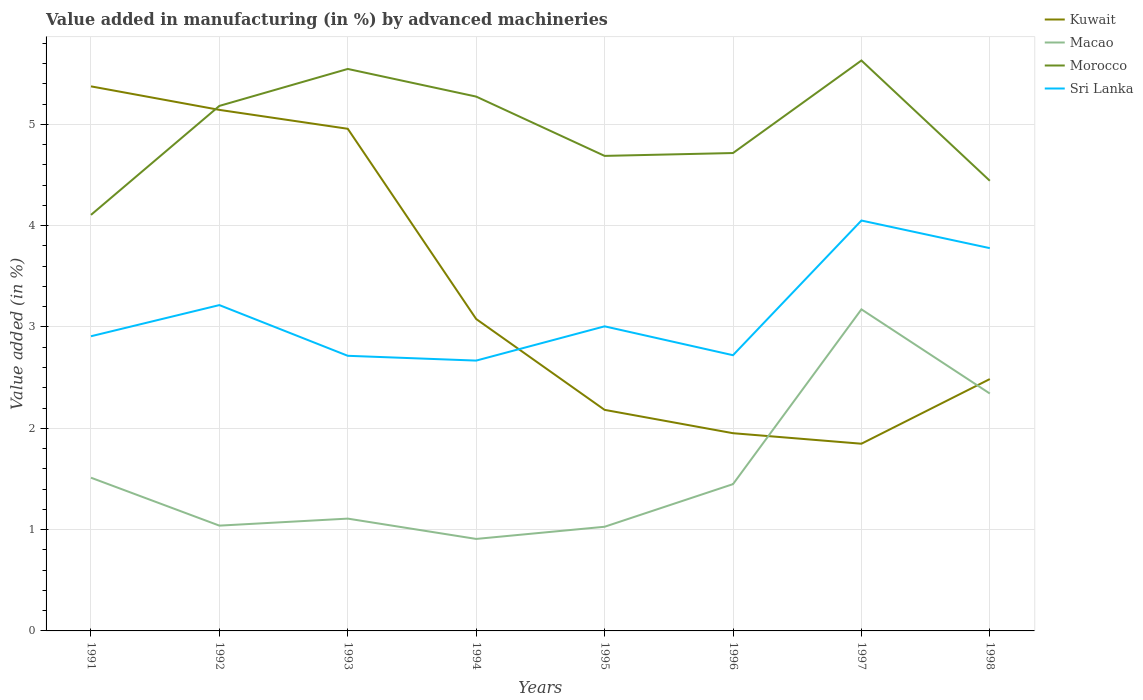Across all years, what is the maximum percentage of value added in manufacturing by advanced machineries in Kuwait?
Make the answer very short. 1.85. What is the total percentage of value added in manufacturing by advanced machineries in Sri Lanka in the graph?
Provide a short and direct response. -1.38. What is the difference between the highest and the second highest percentage of value added in manufacturing by advanced machineries in Macao?
Offer a terse response. 2.27. Is the percentage of value added in manufacturing by advanced machineries in Morocco strictly greater than the percentage of value added in manufacturing by advanced machineries in Sri Lanka over the years?
Your answer should be compact. No. How many lines are there?
Provide a succinct answer. 4. Are the values on the major ticks of Y-axis written in scientific E-notation?
Offer a terse response. No. Does the graph contain grids?
Your answer should be very brief. Yes. How are the legend labels stacked?
Ensure brevity in your answer.  Vertical. What is the title of the graph?
Provide a short and direct response. Value added in manufacturing (in %) by advanced machineries. Does "Liberia" appear as one of the legend labels in the graph?
Ensure brevity in your answer.  No. What is the label or title of the X-axis?
Give a very brief answer. Years. What is the label or title of the Y-axis?
Ensure brevity in your answer.  Value added (in %). What is the Value added (in %) in Kuwait in 1991?
Make the answer very short. 5.38. What is the Value added (in %) in Macao in 1991?
Your response must be concise. 1.51. What is the Value added (in %) of Morocco in 1991?
Your response must be concise. 4.11. What is the Value added (in %) in Sri Lanka in 1991?
Ensure brevity in your answer.  2.91. What is the Value added (in %) of Kuwait in 1992?
Provide a short and direct response. 5.14. What is the Value added (in %) of Macao in 1992?
Keep it short and to the point. 1.04. What is the Value added (in %) in Morocco in 1992?
Give a very brief answer. 5.18. What is the Value added (in %) in Sri Lanka in 1992?
Your answer should be very brief. 3.22. What is the Value added (in %) in Kuwait in 1993?
Your response must be concise. 4.96. What is the Value added (in %) of Macao in 1993?
Give a very brief answer. 1.11. What is the Value added (in %) of Morocco in 1993?
Make the answer very short. 5.55. What is the Value added (in %) of Sri Lanka in 1993?
Provide a short and direct response. 2.72. What is the Value added (in %) in Kuwait in 1994?
Provide a succinct answer. 3.08. What is the Value added (in %) of Macao in 1994?
Your response must be concise. 0.91. What is the Value added (in %) in Morocco in 1994?
Offer a very short reply. 5.27. What is the Value added (in %) of Sri Lanka in 1994?
Your answer should be compact. 2.67. What is the Value added (in %) of Kuwait in 1995?
Ensure brevity in your answer.  2.18. What is the Value added (in %) in Macao in 1995?
Your answer should be very brief. 1.03. What is the Value added (in %) in Morocco in 1995?
Offer a terse response. 4.69. What is the Value added (in %) in Sri Lanka in 1995?
Your answer should be very brief. 3.01. What is the Value added (in %) in Kuwait in 1996?
Your response must be concise. 1.95. What is the Value added (in %) in Macao in 1996?
Your answer should be compact. 1.45. What is the Value added (in %) of Morocco in 1996?
Keep it short and to the point. 4.72. What is the Value added (in %) in Sri Lanka in 1996?
Provide a succinct answer. 2.72. What is the Value added (in %) in Kuwait in 1997?
Offer a very short reply. 1.85. What is the Value added (in %) in Macao in 1997?
Your response must be concise. 3.17. What is the Value added (in %) of Morocco in 1997?
Offer a terse response. 5.63. What is the Value added (in %) in Sri Lanka in 1997?
Keep it short and to the point. 4.05. What is the Value added (in %) in Kuwait in 1998?
Give a very brief answer. 2.49. What is the Value added (in %) of Macao in 1998?
Keep it short and to the point. 2.34. What is the Value added (in %) in Morocco in 1998?
Keep it short and to the point. 4.44. What is the Value added (in %) of Sri Lanka in 1998?
Ensure brevity in your answer.  3.78. Across all years, what is the maximum Value added (in %) in Kuwait?
Make the answer very short. 5.38. Across all years, what is the maximum Value added (in %) in Macao?
Offer a very short reply. 3.17. Across all years, what is the maximum Value added (in %) of Morocco?
Provide a short and direct response. 5.63. Across all years, what is the maximum Value added (in %) of Sri Lanka?
Make the answer very short. 4.05. Across all years, what is the minimum Value added (in %) of Kuwait?
Offer a very short reply. 1.85. Across all years, what is the minimum Value added (in %) in Macao?
Provide a short and direct response. 0.91. Across all years, what is the minimum Value added (in %) of Morocco?
Ensure brevity in your answer.  4.11. Across all years, what is the minimum Value added (in %) in Sri Lanka?
Your answer should be very brief. 2.67. What is the total Value added (in %) of Kuwait in the graph?
Offer a very short reply. 27.02. What is the total Value added (in %) in Macao in the graph?
Your answer should be very brief. 12.56. What is the total Value added (in %) in Morocco in the graph?
Offer a very short reply. 39.59. What is the total Value added (in %) in Sri Lanka in the graph?
Your answer should be compact. 25.07. What is the difference between the Value added (in %) of Kuwait in 1991 and that in 1992?
Offer a very short reply. 0.23. What is the difference between the Value added (in %) of Macao in 1991 and that in 1992?
Offer a very short reply. 0.47. What is the difference between the Value added (in %) of Morocco in 1991 and that in 1992?
Provide a short and direct response. -1.08. What is the difference between the Value added (in %) of Sri Lanka in 1991 and that in 1992?
Keep it short and to the point. -0.31. What is the difference between the Value added (in %) in Kuwait in 1991 and that in 1993?
Provide a succinct answer. 0.42. What is the difference between the Value added (in %) of Macao in 1991 and that in 1993?
Provide a short and direct response. 0.4. What is the difference between the Value added (in %) of Morocco in 1991 and that in 1993?
Offer a terse response. -1.44. What is the difference between the Value added (in %) in Sri Lanka in 1991 and that in 1993?
Provide a succinct answer. 0.19. What is the difference between the Value added (in %) of Kuwait in 1991 and that in 1994?
Give a very brief answer. 2.3. What is the difference between the Value added (in %) in Macao in 1991 and that in 1994?
Offer a very short reply. 0.6. What is the difference between the Value added (in %) in Morocco in 1991 and that in 1994?
Provide a succinct answer. -1.17. What is the difference between the Value added (in %) in Sri Lanka in 1991 and that in 1994?
Make the answer very short. 0.24. What is the difference between the Value added (in %) of Kuwait in 1991 and that in 1995?
Give a very brief answer. 3.19. What is the difference between the Value added (in %) of Macao in 1991 and that in 1995?
Provide a succinct answer. 0.48. What is the difference between the Value added (in %) of Morocco in 1991 and that in 1995?
Make the answer very short. -0.58. What is the difference between the Value added (in %) in Sri Lanka in 1991 and that in 1995?
Your answer should be very brief. -0.1. What is the difference between the Value added (in %) in Kuwait in 1991 and that in 1996?
Make the answer very short. 3.42. What is the difference between the Value added (in %) in Macao in 1991 and that in 1996?
Provide a short and direct response. 0.06. What is the difference between the Value added (in %) in Morocco in 1991 and that in 1996?
Offer a terse response. -0.61. What is the difference between the Value added (in %) in Sri Lanka in 1991 and that in 1996?
Give a very brief answer. 0.19. What is the difference between the Value added (in %) of Kuwait in 1991 and that in 1997?
Your answer should be compact. 3.53. What is the difference between the Value added (in %) of Macao in 1991 and that in 1997?
Your answer should be compact. -1.66. What is the difference between the Value added (in %) of Morocco in 1991 and that in 1997?
Your response must be concise. -1.52. What is the difference between the Value added (in %) in Sri Lanka in 1991 and that in 1997?
Offer a terse response. -1.14. What is the difference between the Value added (in %) in Kuwait in 1991 and that in 1998?
Provide a short and direct response. 2.89. What is the difference between the Value added (in %) of Macao in 1991 and that in 1998?
Make the answer very short. -0.83. What is the difference between the Value added (in %) of Morocco in 1991 and that in 1998?
Give a very brief answer. -0.34. What is the difference between the Value added (in %) of Sri Lanka in 1991 and that in 1998?
Your answer should be compact. -0.87. What is the difference between the Value added (in %) in Kuwait in 1992 and that in 1993?
Offer a terse response. 0.19. What is the difference between the Value added (in %) of Macao in 1992 and that in 1993?
Your answer should be compact. -0.07. What is the difference between the Value added (in %) of Morocco in 1992 and that in 1993?
Keep it short and to the point. -0.36. What is the difference between the Value added (in %) in Sri Lanka in 1992 and that in 1993?
Give a very brief answer. 0.5. What is the difference between the Value added (in %) in Kuwait in 1992 and that in 1994?
Keep it short and to the point. 2.06. What is the difference between the Value added (in %) in Macao in 1992 and that in 1994?
Your answer should be compact. 0.13. What is the difference between the Value added (in %) in Morocco in 1992 and that in 1994?
Offer a very short reply. -0.09. What is the difference between the Value added (in %) of Sri Lanka in 1992 and that in 1994?
Your answer should be compact. 0.55. What is the difference between the Value added (in %) in Kuwait in 1992 and that in 1995?
Provide a succinct answer. 2.96. What is the difference between the Value added (in %) of Macao in 1992 and that in 1995?
Your answer should be compact. 0.01. What is the difference between the Value added (in %) of Morocco in 1992 and that in 1995?
Your answer should be compact. 0.49. What is the difference between the Value added (in %) of Sri Lanka in 1992 and that in 1995?
Offer a terse response. 0.21. What is the difference between the Value added (in %) of Kuwait in 1992 and that in 1996?
Make the answer very short. 3.19. What is the difference between the Value added (in %) of Macao in 1992 and that in 1996?
Your answer should be very brief. -0.41. What is the difference between the Value added (in %) of Morocco in 1992 and that in 1996?
Offer a terse response. 0.47. What is the difference between the Value added (in %) of Sri Lanka in 1992 and that in 1996?
Your response must be concise. 0.49. What is the difference between the Value added (in %) of Kuwait in 1992 and that in 1997?
Provide a short and direct response. 3.3. What is the difference between the Value added (in %) of Macao in 1992 and that in 1997?
Keep it short and to the point. -2.13. What is the difference between the Value added (in %) of Morocco in 1992 and that in 1997?
Offer a very short reply. -0.45. What is the difference between the Value added (in %) of Sri Lanka in 1992 and that in 1997?
Your response must be concise. -0.83. What is the difference between the Value added (in %) in Kuwait in 1992 and that in 1998?
Your response must be concise. 2.66. What is the difference between the Value added (in %) of Macao in 1992 and that in 1998?
Keep it short and to the point. -1.3. What is the difference between the Value added (in %) of Morocco in 1992 and that in 1998?
Give a very brief answer. 0.74. What is the difference between the Value added (in %) in Sri Lanka in 1992 and that in 1998?
Offer a terse response. -0.56. What is the difference between the Value added (in %) in Kuwait in 1993 and that in 1994?
Keep it short and to the point. 1.88. What is the difference between the Value added (in %) of Macao in 1993 and that in 1994?
Provide a succinct answer. 0.2. What is the difference between the Value added (in %) in Morocco in 1993 and that in 1994?
Your response must be concise. 0.27. What is the difference between the Value added (in %) in Sri Lanka in 1993 and that in 1994?
Offer a very short reply. 0.05. What is the difference between the Value added (in %) of Kuwait in 1993 and that in 1995?
Your response must be concise. 2.77. What is the difference between the Value added (in %) in Macao in 1993 and that in 1995?
Your response must be concise. 0.08. What is the difference between the Value added (in %) of Morocco in 1993 and that in 1995?
Ensure brevity in your answer.  0.86. What is the difference between the Value added (in %) in Sri Lanka in 1993 and that in 1995?
Provide a short and direct response. -0.29. What is the difference between the Value added (in %) of Kuwait in 1993 and that in 1996?
Offer a terse response. 3. What is the difference between the Value added (in %) in Macao in 1993 and that in 1996?
Keep it short and to the point. -0.34. What is the difference between the Value added (in %) of Morocco in 1993 and that in 1996?
Your answer should be very brief. 0.83. What is the difference between the Value added (in %) in Sri Lanka in 1993 and that in 1996?
Make the answer very short. -0.01. What is the difference between the Value added (in %) in Kuwait in 1993 and that in 1997?
Offer a very short reply. 3.11. What is the difference between the Value added (in %) in Macao in 1993 and that in 1997?
Provide a short and direct response. -2.07. What is the difference between the Value added (in %) in Morocco in 1993 and that in 1997?
Provide a short and direct response. -0.08. What is the difference between the Value added (in %) of Sri Lanka in 1993 and that in 1997?
Make the answer very short. -1.34. What is the difference between the Value added (in %) of Kuwait in 1993 and that in 1998?
Your answer should be very brief. 2.47. What is the difference between the Value added (in %) of Macao in 1993 and that in 1998?
Your response must be concise. -1.23. What is the difference between the Value added (in %) in Morocco in 1993 and that in 1998?
Ensure brevity in your answer.  1.1. What is the difference between the Value added (in %) of Sri Lanka in 1993 and that in 1998?
Offer a terse response. -1.06. What is the difference between the Value added (in %) of Kuwait in 1994 and that in 1995?
Offer a very short reply. 0.9. What is the difference between the Value added (in %) of Macao in 1994 and that in 1995?
Give a very brief answer. -0.12. What is the difference between the Value added (in %) of Morocco in 1994 and that in 1995?
Provide a succinct answer. 0.59. What is the difference between the Value added (in %) of Sri Lanka in 1994 and that in 1995?
Your response must be concise. -0.34. What is the difference between the Value added (in %) in Kuwait in 1994 and that in 1996?
Offer a very short reply. 1.13. What is the difference between the Value added (in %) in Macao in 1994 and that in 1996?
Keep it short and to the point. -0.54. What is the difference between the Value added (in %) in Morocco in 1994 and that in 1996?
Provide a short and direct response. 0.56. What is the difference between the Value added (in %) in Sri Lanka in 1994 and that in 1996?
Offer a terse response. -0.05. What is the difference between the Value added (in %) in Kuwait in 1994 and that in 1997?
Your response must be concise. 1.23. What is the difference between the Value added (in %) in Macao in 1994 and that in 1997?
Keep it short and to the point. -2.27. What is the difference between the Value added (in %) in Morocco in 1994 and that in 1997?
Ensure brevity in your answer.  -0.36. What is the difference between the Value added (in %) of Sri Lanka in 1994 and that in 1997?
Give a very brief answer. -1.38. What is the difference between the Value added (in %) of Kuwait in 1994 and that in 1998?
Ensure brevity in your answer.  0.59. What is the difference between the Value added (in %) in Macao in 1994 and that in 1998?
Your response must be concise. -1.44. What is the difference between the Value added (in %) of Morocco in 1994 and that in 1998?
Your answer should be very brief. 0.83. What is the difference between the Value added (in %) in Sri Lanka in 1994 and that in 1998?
Make the answer very short. -1.11. What is the difference between the Value added (in %) in Kuwait in 1995 and that in 1996?
Make the answer very short. 0.23. What is the difference between the Value added (in %) in Macao in 1995 and that in 1996?
Give a very brief answer. -0.42. What is the difference between the Value added (in %) in Morocco in 1995 and that in 1996?
Ensure brevity in your answer.  -0.03. What is the difference between the Value added (in %) in Sri Lanka in 1995 and that in 1996?
Ensure brevity in your answer.  0.28. What is the difference between the Value added (in %) of Kuwait in 1995 and that in 1997?
Keep it short and to the point. 0.33. What is the difference between the Value added (in %) of Macao in 1995 and that in 1997?
Keep it short and to the point. -2.15. What is the difference between the Value added (in %) of Morocco in 1995 and that in 1997?
Provide a short and direct response. -0.94. What is the difference between the Value added (in %) of Sri Lanka in 1995 and that in 1997?
Make the answer very short. -1.04. What is the difference between the Value added (in %) in Kuwait in 1995 and that in 1998?
Offer a terse response. -0.3. What is the difference between the Value added (in %) in Macao in 1995 and that in 1998?
Make the answer very short. -1.31. What is the difference between the Value added (in %) in Morocco in 1995 and that in 1998?
Offer a very short reply. 0.25. What is the difference between the Value added (in %) of Sri Lanka in 1995 and that in 1998?
Your answer should be very brief. -0.77. What is the difference between the Value added (in %) in Kuwait in 1996 and that in 1997?
Ensure brevity in your answer.  0.1. What is the difference between the Value added (in %) in Macao in 1996 and that in 1997?
Keep it short and to the point. -1.73. What is the difference between the Value added (in %) in Morocco in 1996 and that in 1997?
Give a very brief answer. -0.91. What is the difference between the Value added (in %) of Sri Lanka in 1996 and that in 1997?
Keep it short and to the point. -1.33. What is the difference between the Value added (in %) of Kuwait in 1996 and that in 1998?
Offer a terse response. -0.53. What is the difference between the Value added (in %) of Macao in 1996 and that in 1998?
Give a very brief answer. -0.89. What is the difference between the Value added (in %) in Morocco in 1996 and that in 1998?
Make the answer very short. 0.27. What is the difference between the Value added (in %) in Sri Lanka in 1996 and that in 1998?
Offer a terse response. -1.06. What is the difference between the Value added (in %) in Kuwait in 1997 and that in 1998?
Offer a very short reply. -0.64. What is the difference between the Value added (in %) of Macao in 1997 and that in 1998?
Give a very brief answer. 0.83. What is the difference between the Value added (in %) in Morocco in 1997 and that in 1998?
Provide a succinct answer. 1.19. What is the difference between the Value added (in %) in Sri Lanka in 1997 and that in 1998?
Your answer should be very brief. 0.27. What is the difference between the Value added (in %) of Kuwait in 1991 and the Value added (in %) of Macao in 1992?
Your answer should be very brief. 4.34. What is the difference between the Value added (in %) of Kuwait in 1991 and the Value added (in %) of Morocco in 1992?
Keep it short and to the point. 0.19. What is the difference between the Value added (in %) in Kuwait in 1991 and the Value added (in %) in Sri Lanka in 1992?
Offer a terse response. 2.16. What is the difference between the Value added (in %) in Macao in 1991 and the Value added (in %) in Morocco in 1992?
Provide a short and direct response. -3.67. What is the difference between the Value added (in %) in Macao in 1991 and the Value added (in %) in Sri Lanka in 1992?
Your response must be concise. -1.7. What is the difference between the Value added (in %) of Morocco in 1991 and the Value added (in %) of Sri Lanka in 1992?
Provide a succinct answer. 0.89. What is the difference between the Value added (in %) in Kuwait in 1991 and the Value added (in %) in Macao in 1993?
Provide a short and direct response. 4.27. What is the difference between the Value added (in %) in Kuwait in 1991 and the Value added (in %) in Morocco in 1993?
Provide a succinct answer. -0.17. What is the difference between the Value added (in %) in Kuwait in 1991 and the Value added (in %) in Sri Lanka in 1993?
Make the answer very short. 2.66. What is the difference between the Value added (in %) of Macao in 1991 and the Value added (in %) of Morocco in 1993?
Give a very brief answer. -4.03. What is the difference between the Value added (in %) of Macao in 1991 and the Value added (in %) of Sri Lanka in 1993?
Your response must be concise. -1.2. What is the difference between the Value added (in %) of Morocco in 1991 and the Value added (in %) of Sri Lanka in 1993?
Keep it short and to the point. 1.39. What is the difference between the Value added (in %) in Kuwait in 1991 and the Value added (in %) in Macao in 1994?
Ensure brevity in your answer.  4.47. What is the difference between the Value added (in %) of Kuwait in 1991 and the Value added (in %) of Morocco in 1994?
Ensure brevity in your answer.  0.1. What is the difference between the Value added (in %) of Kuwait in 1991 and the Value added (in %) of Sri Lanka in 1994?
Provide a succinct answer. 2.71. What is the difference between the Value added (in %) of Macao in 1991 and the Value added (in %) of Morocco in 1994?
Your answer should be very brief. -3.76. What is the difference between the Value added (in %) of Macao in 1991 and the Value added (in %) of Sri Lanka in 1994?
Give a very brief answer. -1.16. What is the difference between the Value added (in %) of Morocco in 1991 and the Value added (in %) of Sri Lanka in 1994?
Offer a very short reply. 1.44. What is the difference between the Value added (in %) in Kuwait in 1991 and the Value added (in %) in Macao in 1995?
Provide a succinct answer. 4.35. What is the difference between the Value added (in %) of Kuwait in 1991 and the Value added (in %) of Morocco in 1995?
Ensure brevity in your answer.  0.69. What is the difference between the Value added (in %) in Kuwait in 1991 and the Value added (in %) in Sri Lanka in 1995?
Provide a succinct answer. 2.37. What is the difference between the Value added (in %) of Macao in 1991 and the Value added (in %) of Morocco in 1995?
Keep it short and to the point. -3.18. What is the difference between the Value added (in %) of Macao in 1991 and the Value added (in %) of Sri Lanka in 1995?
Your answer should be compact. -1.49. What is the difference between the Value added (in %) of Morocco in 1991 and the Value added (in %) of Sri Lanka in 1995?
Your answer should be very brief. 1.1. What is the difference between the Value added (in %) of Kuwait in 1991 and the Value added (in %) of Macao in 1996?
Give a very brief answer. 3.93. What is the difference between the Value added (in %) in Kuwait in 1991 and the Value added (in %) in Morocco in 1996?
Your answer should be very brief. 0.66. What is the difference between the Value added (in %) of Kuwait in 1991 and the Value added (in %) of Sri Lanka in 1996?
Provide a succinct answer. 2.65. What is the difference between the Value added (in %) in Macao in 1991 and the Value added (in %) in Morocco in 1996?
Offer a very short reply. -3.2. What is the difference between the Value added (in %) in Macao in 1991 and the Value added (in %) in Sri Lanka in 1996?
Give a very brief answer. -1.21. What is the difference between the Value added (in %) of Morocco in 1991 and the Value added (in %) of Sri Lanka in 1996?
Offer a terse response. 1.39. What is the difference between the Value added (in %) of Kuwait in 1991 and the Value added (in %) of Macao in 1997?
Your answer should be very brief. 2.2. What is the difference between the Value added (in %) of Kuwait in 1991 and the Value added (in %) of Morocco in 1997?
Provide a short and direct response. -0.26. What is the difference between the Value added (in %) in Kuwait in 1991 and the Value added (in %) in Sri Lanka in 1997?
Provide a short and direct response. 1.32. What is the difference between the Value added (in %) of Macao in 1991 and the Value added (in %) of Morocco in 1997?
Offer a terse response. -4.12. What is the difference between the Value added (in %) of Macao in 1991 and the Value added (in %) of Sri Lanka in 1997?
Your answer should be compact. -2.54. What is the difference between the Value added (in %) in Morocco in 1991 and the Value added (in %) in Sri Lanka in 1997?
Your answer should be compact. 0.06. What is the difference between the Value added (in %) in Kuwait in 1991 and the Value added (in %) in Macao in 1998?
Your response must be concise. 3.03. What is the difference between the Value added (in %) of Kuwait in 1991 and the Value added (in %) of Morocco in 1998?
Make the answer very short. 0.93. What is the difference between the Value added (in %) in Kuwait in 1991 and the Value added (in %) in Sri Lanka in 1998?
Offer a very short reply. 1.6. What is the difference between the Value added (in %) of Macao in 1991 and the Value added (in %) of Morocco in 1998?
Your answer should be compact. -2.93. What is the difference between the Value added (in %) of Macao in 1991 and the Value added (in %) of Sri Lanka in 1998?
Offer a terse response. -2.27. What is the difference between the Value added (in %) in Morocco in 1991 and the Value added (in %) in Sri Lanka in 1998?
Provide a succinct answer. 0.33. What is the difference between the Value added (in %) in Kuwait in 1992 and the Value added (in %) in Macao in 1993?
Give a very brief answer. 4.03. What is the difference between the Value added (in %) of Kuwait in 1992 and the Value added (in %) of Morocco in 1993?
Provide a short and direct response. -0.4. What is the difference between the Value added (in %) in Kuwait in 1992 and the Value added (in %) in Sri Lanka in 1993?
Ensure brevity in your answer.  2.43. What is the difference between the Value added (in %) of Macao in 1992 and the Value added (in %) of Morocco in 1993?
Offer a terse response. -4.51. What is the difference between the Value added (in %) of Macao in 1992 and the Value added (in %) of Sri Lanka in 1993?
Provide a short and direct response. -1.68. What is the difference between the Value added (in %) of Morocco in 1992 and the Value added (in %) of Sri Lanka in 1993?
Give a very brief answer. 2.47. What is the difference between the Value added (in %) of Kuwait in 1992 and the Value added (in %) of Macao in 1994?
Provide a succinct answer. 4.23. What is the difference between the Value added (in %) in Kuwait in 1992 and the Value added (in %) in Morocco in 1994?
Provide a short and direct response. -0.13. What is the difference between the Value added (in %) in Kuwait in 1992 and the Value added (in %) in Sri Lanka in 1994?
Give a very brief answer. 2.47. What is the difference between the Value added (in %) in Macao in 1992 and the Value added (in %) in Morocco in 1994?
Your response must be concise. -4.23. What is the difference between the Value added (in %) in Macao in 1992 and the Value added (in %) in Sri Lanka in 1994?
Your response must be concise. -1.63. What is the difference between the Value added (in %) of Morocco in 1992 and the Value added (in %) of Sri Lanka in 1994?
Make the answer very short. 2.51. What is the difference between the Value added (in %) in Kuwait in 1992 and the Value added (in %) in Macao in 1995?
Offer a very short reply. 4.11. What is the difference between the Value added (in %) in Kuwait in 1992 and the Value added (in %) in Morocco in 1995?
Offer a very short reply. 0.45. What is the difference between the Value added (in %) of Kuwait in 1992 and the Value added (in %) of Sri Lanka in 1995?
Offer a terse response. 2.14. What is the difference between the Value added (in %) of Macao in 1992 and the Value added (in %) of Morocco in 1995?
Give a very brief answer. -3.65. What is the difference between the Value added (in %) in Macao in 1992 and the Value added (in %) in Sri Lanka in 1995?
Keep it short and to the point. -1.97. What is the difference between the Value added (in %) in Morocco in 1992 and the Value added (in %) in Sri Lanka in 1995?
Keep it short and to the point. 2.18. What is the difference between the Value added (in %) of Kuwait in 1992 and the Value added (in %) of Macao in 1996?
Offer a very short reply. 3.69. What is the difference between the Value added (in %) in Kuwait in 1992 and the Value added (in %) in Morocco in 1996?
Offer a terse response. 0.43. What is the difference between the Value added (in %) of Kuwait in 1992 and the Value added (in %) of Sri Lanka in 1996?
Your response must be concise. 2.42. What is the difference between the Value added (in %) of Macao in 1992 and the Value added (in %) of Morocco in 1996?
Ensure brevity in your answer.  -3.68. What is the difference between the Value added (in %) in Macao in 1992 and the Value added (in %) in Sri Lanka in 1996?
Provide a short and direct response. -1.68. What is the difference between the Value added (in %) in Morocco in 1992 and the Value added (in %) in Sri Lanka in 1996?
Provide a short and direct response. 2.46. What is the difference between the Value added (in %) of Kuwait in 1992 and the Value added (in %) of Macao in 1997?
Offer a terse response. 1.97. What is the difference between the Value added (in %) in Kuwait in 1992 and the Value added (in %) in Morocco in 1997?
Provide a succinct answer. -0.49. What is the difference between the Value added (in %) of Kuwait in 1992 and the Value added (in %) of Sri Lanka in 1997?
Keep it short and to the point. 1.09. What is the difference between the Value added (in %) in Macao in 1992 and the Value added (in %) in Morocco in 1997?
Your answer should be very brief. -4.59. What is the difference between the Value added (in %) in Macao in 1992 and the Value added (in %) in Sri Lanka in 1997?
Offer a terse response. -3.01. What is the difference between the Value added (in %) of Morocco in 1992 and the Value added (in %) of Sri Lanka in 1997?
Give a very brief answer. 1.13. What is the difference between the Value added (in %) in Kuwait in 1992 and the Value added (in %) in Macao in 1998?
Your answer should be very brief. 2.8. What is the difference between the Value added (in %) in Kuwait in 1992 and the Value added (in %) in Morocco in 1998?
Offer a terse response. 0.7. What is the difference between the Value added (in %) of Kuwait in 1992 and the Value added (in %) of Sri Lanka in 1998?
Offer a very short reply. 1.36. What is the difference between the Value added (in %) in Macao in 1992 and the Value added (in %) in Morocco in 1998?
Ensure brevity in your answer.  -3.4. What is the difference between the Value added (in %) of Macao in 1992 and the Value added (in %) of Sri Lanka in 1998?
Ensure brevity in your answer.  -2.74. What is the difference between the Value added (in %) of Morocco in 1992 and the Value added (in %) of Sri Lanka in 1998?
Your answer should be compact. 1.4. What is the difference between the Value added (in %) of Kuwait in 1993 and the Value added (in %) of Macao in 1994?
Offer a very short reply. 4.05. What is the difference between the Value added (in %) of Kuwait in 1993 and the Value added (in %) of Morocco in 1994?
Make the answer very short. -0.32. What is the difference between the Value added (in %) in Kuwait in 1993 and the Value added (in %) in Sri Lanka in 1994?
Provide a succinct answer. 2.29. What is the difference between the Value added (in %) in Macao in 1993 and the Value added (in %) in Morocco in 1994?
Your response must be concise. -4.17. What is the difference between the Value added (in %) in Macao in 1993 and the Value added (in %) in Sri Lanka in 1994?
Your answer should be very brief. -1.56. What is the difference between the Value added (in %) of Morocco in 1993 and the Value added (in %) of Sri Lanka in 1994?
Make the answer very short. 2.88. What is the difference between the Value added (in %) of Kuwait in 1993 and the Value added (in %) of Macao in 1995?
Your response must be concise. 3.93. What is the difference between the Value added (in %) of Kuwait in 1993 and the Value added (in %) of Morocco in 1995?
Your answer should be compact. 0.27. What is the difference between the Value added (in %) in Kuwait in 1993 and the Value added (in %) in Sri Lanka in 1995?
Your answer should be compact. 1.95. What is the difference between the Value added (in %) of Macao in 1993 and the Value added (in %) of Morocco in 1995?
Your answer should be very brief. -3.58. What is the difference between the Value added (in %) of Macao in 1993 and the Value added (in %) of Sri Lanka in 1995?
Ensure brevity in your answer.  -1.9. What is the difference between the Value added (in %) in Morocco in 1993 and the Value added (in %) in Sri Lanka in 1995?
Provide a succinct answer. 2.54. What is the difference between the Value added (in %) of Kuwait in 1993 and the Value added (in %) of Macao in 1996?
Your response must be concise. 3.51. What is the difference between the Value added (in %) in Kuwait in 1993 and the Value added (in %) in Morocco in 1996?
Your answer should be compact. 0.24. What is the difference between the Value added (in %) in Kuwait in 1993 and the Value added (in %) in Sri Lanka in 1996?
Your answer should be compact. 2.23. What is the difference between the Value added (in %) in Macao in 1993 and the Value added (in %) in Morocco in 1996?
Ensure brevity in your answer.  -3.61. What is the difference between the Value added (in %) in Macao in 1993 and the Value added (in %) in Sri Lanka in 1996?
Your response must be concise. -1.61. What is the difference between the Value added (in %) of Morocco in 1993 and the Value added (in %) of Sri Lanka in 1996?
Give a very brief answer. 2.83. What is the difference between the Value added (in %) in Kuwait in 1993 and the Value added (in %) in Macao in 1997?
Your answer should be very brief. 1.78. What is the difference between the Value added (in %) in Kuwait in 1993 and the Value added (in %) in Morocco in 1997?
Make the answer very short. -0.67. What is the difference between the Value added (in %) in Kuwait in 1993 and the Value added (in %) in Sri Lanka in 1997?
Provide a succinct answer. 0.91. What is the difference between the Value added (in %) in Macao in 1993 and the Value added (in %) in Morocco in 1997?
Offer a very short reply. -4.52. What is the difference between the Value added (in %) of Macao in 1993 and the Value added (in %) of Sri Lanka in 1997?
Your answer should be compact. -2.94. What is the difference between the Value added (in %) of Morocco in 1993 and the Value added (in %) of Sri Lanka in 1997?
Offer a very short reply. 1.5. What is the difference between the Value added (in %) in Kuwait in 1993 and the Value added (in %) in Macao in 1998?
Make the answer very short. 2.61. What is the difference between the Value added (in %) in Kuwait in 1993 and the Value added (in %) in Morocco in 1998?
Your answer should be compact. 0.51. What is the difference between the Value added (in %) in Kuwait in 1993 and the Value added (in %) in Sri Lanka in 1998?
Your response must be concise. 1.18. What is the difference between the Value added (in %) of Macao in 1993 and the Value added (in %) of Morocco in 1998?
Offer a very short reply. -3.33. What is the difference between the Value added (in %) of Macao in 1993 and the Value added (in %) of Sri Lanka in 1998?
Provide a succinct answer. -2.67. What is the difference between the Value added (in %) in Morocco in 1993 and the Value added (in %) in Sri Lanka in 1998?
Offer a very short reply. 1.77. What is the difference between the Value added (in %) in Kuwait in 1994 and the Value added (in %) in Macao in 1995?
Your answer should be compact. 2.05. What is the difference between the Value added (in %) in Kuwait in 1994 and the Value added (in %) in Morocco in 1995?
Give a very brief answer. -1.61. What is the difference between the Value added (in %) of Kuwait in 1994 and the Value added (in %) of Sri Lanka in 1995?
Keep it short and to the point. 0.07. What is the difference between the Value added (in %) of Macao in 1994 and the Value added (in %) of Morocco in 1995?
Make the answer very short. -3.78. What is the difference between the Value added (in %) in Macao in 1994 and the Value added (in %) in Sri Lanka in 1995?
Your answer should be very brief. -2.1. What is the difference between the Value added (in %) in Morocco in 1994 and the Value added (in %) in Sri Lanka in 1995?
Keep it short and to the point. 2.27. What is the difference between the Value added (in %) in Kuwait in 1994 and the Value added (in %) in Macao in 1996?
Provide a short and direct response. 1.63. What is the difference between the Value added (in %) in Kuwait in 1994 and the Value added (in %) in Morocco in 1996?
Ensure brevity in your answer.  -1.64. What is the difference between the Value added (in %) of Kuwait in 1994 and the Value added (in %) of Sri Lanka in 1996?
Offer a very short reply. 0.36. What is the difference between the Value added (in %) of Macao in 1994 and the Value added (in %) of Morocco in 1996?
Provide a succinct answer. -3.81. What is the difference between the Value added (in %) in Macao in 1994 and the Value added (in %) in Sri Lanka in 1996?
Your answer should be very brief. -1.81. What is the difference between the Value added (in %) in Morocco in 1994 and the Value added (in %) in Sri Lanka in 1996?
Offer a terse response. 2.55. What is the difference between the Value added (in %) in Kuwait in 1994 and the Value added (in %) in Macao in 1997?
Offer a very short reply. -0.1. What is the difference between the Value added (in %) in Kuwait in 1994 and the Value added (in %) in Morocco in 1997?
Your answer should be very brief. -2.55. What is the difference between the Value added (in %) of Kuwait in 1994 and the Value added (in %) of Sri Lanka in 1997?
Your answer should be compact. -0.97. What is the difference between the Value added (in %) of Macao in 1994 and the Value added (in %) of Morocco in 1997?
Your answer should be compact. -4.72. What is the difference between the Value added (in %) in Macao in 1994 and the Value added (in %) in Sri Lanka in 1997?
Give a very brief answer. -3.14. What is the difference between the Value added (in %) of Morocco in 1994 and the Value added (in %) of Sri Lanka in 1997?
Ensure brevity in your answer.  1.22. What is the difference between the Value added (in %) in Kuwait in 1994 and the Value added (in %) in Macao in 1998?
Your response must be concise. 0.74. What is the difference between the Value added (in %) of Kuwait in 1994 and the Value added (in %) of Morocco in 1998?
Provide a short and direct response. -1.36. What is the difference between the Value added (in %) in Kuwait in 1994 and the Value added (in %) in Sri Lanka in 1998?
Provide a succinct answer. -0.7. What is the difference between the Value added (in %) of Macao in 1994 and the Value added (in %) of Morocco in 1998?
Make the answer very short. -3.54. What is the difference between the Value added (in %) of Macao in 1994 and the Value added (in %) of Sri Lanka in 1998?
Give a very brief answer. -2.87. What is the difference between the Value added (in %) in Morocco in 1994 and the Value added (in %) in Sri Lanka in 1998?
Offer a very short reply. 1.5. What is the difference between the Value added (in %) of Kuwait in 1995 and the Value added (in %) of Macao in 1996?
Your answer should be very brief. 0.73. What is the difference between the Value added (in %) of Kuwait in 1995 and the Value added (in %) of Morocco in 1996?
Make the answer very short. -2.53. What is the difference between the Value added (in %) of Kuwait in 1995 and the Value added (in %) of Sri Lanka in 1996?
Keep it short and to the point. -0.54. What is the difference between the Value added (in %) in Macao in 1995 and the Value added (in %) in Morocco in 1996?
Your answer should be very brief. -3.69. What is the difference between the Value added (in %) of Macao in 1995 and the Value added (in %) of Sri Lanka in 1996?
Give a very brief answer. -1.69. What is the difference between the Value added (in %) of Morocco in 1995 and the Value added (in %) of Sri Lanka in 1996?
Offer a terse response. 1.97. What is the difference between the Value added (in %) in Kuwait in 1995 and the Value added (in %) in Macao in 1997?
Your answer should be very brief. -0.99. What is the difference between the Value added (in %) of Kuwait in 1995 and the Value added (in %) of Morocco in 1997?
Provide a short and direct response. -3.45. What is the difference between the Value added (in %) of Kuwait in 1995 and the Value added (in %) of Sri Lanka in 1997?
Give a very brief answer. -1.87. What is the difference between the Value added (in %) in Macao in 1995 and the Value added (in %) in Morocco in 1997?
Make the answer very short. -4.6. What is the difference between the Value added (in %) in Macao in 1995 and the Value added (in %) in Sri Lanka in 1997?
Provide a short and direct response. -3.02. What is the difference between the Value added (in %) of Morocco in 1995 and the Value added (in %) of Sri Lanka in 1997?
Ensure brevity in your answer.  0.64. What is the difference between the Value added (in %) of Kuwait in 1995 and the Value added (in %) of Macao in 1998?
Ensure brevity in your answer.  -0.16. What is the difference between the Value added (in %) in Kuwait in 1995 and the Value added (in %) in Morocco in 1998?
Your response must be concise. -2.26. What is the difference between the Value added (in %) in Kuwait in 1995 and the Value added (in %) in Sri Lanka in 1998?
Provide a short and direct response. -1.6. What is the difference between the Value added (in %) of Macao in 1995 and the Value added (in %) of Morocco in 1998?
Your response must be concise. -3.42. What is the difference between the Value added (in %) in Macao in 1995 and the Value added (in %) in Sri Lanka in 1998?
Provide a short and direct response. -2.75. What is the difference between the Value added (in %) of Morocco in 1995 and the Value added (in %) of Sri Lanka in 1998?
Your answer should be very brief. 0.91. What is the difference between the Value added (in %) in Kuwait in 1996 and the Value added (in %) in Macao in 1997?
Offer a very short reply. -1.22. What is the difference between the Value added (in %) of Kuwait in 1996 and the Value added (in %) of Morocco in 1997?
Offer a very short reply. -3.68. What is the difference between the Value added (in %) of Kuwait in 1996 and the Value added (in %) of Sri Lanka in 1997?
Keep it short and to the point. -2.1. What is the difference between the Value added (in %) in Macao in 1996 and the Value added (in %) in Morocco in 1997?
Provide a succinct answer. -4.18. What is the difference between the Value added (in %) of Macao in 1996 and the Value added (in %) of Sri Lanka in 1997?
Give a very brief answer. -2.6. What is the difference between the Value added (in %) of Morocco in 1996 and the Value added (in %) of Sri Lanka in 1997?
Give a very brief answer. 0.67. What is the difference between the Value added (in %) in Kuwait in 1996 and the Value added (in %) in Macao in 1998?
Make the answer very short. -0.39. What is the difference between the Value added (in %) of Kuwait in 1996 and the Value added (in %) of Morocco in 1998?
Your response must be concise. -2.49. What is the difference between the Value added (in %) in Kuwait in 1996 and the Value added (in %) in Sri Lanka in 1998?
Provide a short and direct response. -1.83. What is the difference between the Value added (in %) in Macao in 1996 and the Value added (in %) in Morocco in 1998?
Your answer should be compact. -2.99. What is the difference between the Value added (in %) in Macao in 1996 and the Value added (in %) in Sri Lanka in 1998?
Make the answer very short. -2.33. What is the difference between the Value added (in %) in Morocco in 1996 and the Value added (in %) in Sri Lanka in 1998?
Your response must be concise. 0.94. What is the difference between the Value added (in %) of Kuwait in 1997 and the Value added (in %) of Macao in 1998?
Make the answer very short. -0.5. What is the difference between the Value added (in %) of Kuwait in 1997 and the Value added (in %) of Morocco in 1998?
Keep it short and to the point. -2.6. What is the difference between the Value added (in %) in Kuwait in 1997 and the Value added (in %) in Sri Lanka in 1998?
Give a very brief answer. -1.93. What is the difference between the Value added (in %) of Macao in 1997 and the Value added (in %) of Morocco in 1998?
Keep it short and to the point. -1.27. What is the difference between the Value added (in %) of Macao in 1997 and the Value added (in %) of Sri Lanka in 1998?
Your answer should be very brief. -0.6. What is the difference between the Value added (in %) in Morocco in 1997 and the Value added (in %) in Sri Lanka in 1998?
Give a very brief answer. 1.85. What is the average Value added (in %) of Kuwait per year?
Ensure brevity in your answer.  3.38. What is the average Value added (in %) of Macao per year?
Keep it short and to the point. 1.57. What is the average Value added (in %) of Morocco per year?
Make the answer very short. 4.95. What is the average Value added (in %) of Sri Lanka per year?
Your answer should be compact. 3.13. In the year 1991, what is the difference between the Value added (in %) of Kuwait and Value added (in %) of Macao?
Offer a terse response. 3.86. In the year 1991, what is the difference between the Value added (in %) of Kuwait and Value added (in %) of Morocco?
Offer a terse response. 1.27. In the year 1991, what is the difference between the Value added (in %) in Kuwait and Value added (in %) in Sri Lanka?
Make the answer very short. 2.47. In the year 1991, what is the difference between the Value added (in %) in Macao and Value added (in %) in Morocco?
Keep it short and to the point. -2.59. In the year 1991, what is the difference between the Value added (in %) in Macao and Value added (in %) in Sri Lanka?
Make the answer very short. -1.4. In the year 1991, what is the difference between the Value added (in %) of Morocco and Value added (in %) of Sri Lanka?
Your answer should be compact. 1.2. In the year 1992, what is the difference between the Value added (in %) in Kuwait and Value added (in %) in Macao?
Ensure brevity in your answer.  4.1. In the year 1992, what is the difference between the Value added (in %) of Kuwait and Value added (in %) of Morocco?
Make the answer very short. -0.04. In the year 1992, what is the difference between the Value added (in %) in Kuwait and Value added (in %) in Sri Lanka?
Your response must be concise. 1.93. In the year 1992, what is the difference between the Value added (in %) of Macao and Value added (in %) of Morocco?
Give a very brief answer. -4.14. In the year 1992, what is the difference between the Value added (in %) in Macao and Value added (in %) in Sri Lanka?
Ensure brevity in your answer.  -2.18. In the year 1992, what is the difference between the Value added (in %) in Morocco and Value added (in %) in Sri Lanka?
Make the answer very short. 1.97. In the year 1993, what is the difference between the Value added (in %) in Kuwait and Value added (in %) in Macao?
Your response must be concise. 3.85. In the year 1993, what is the difference between the Value added (in %) in Kuwait and Value added (in %) in Morocco?
Keep it short and to the point. -0.59. In the year 1993, what is the difference between the Value added (in %) in Kuwait and Value added (in %) in Sri Lanka?
Provide a short and direct response. 2.24. In the year 1993, what is the difference between the Value added (in %) in Macao and Value added (in %) in Morocco?
Offer a terse response. -4.44. In the year 1993, what is the difference between the Value added (in %) of Macao and Value added (in %) of Sri Lanka?
Make the answer very short. -1.61. In the year 1993, what is the difference between the Value added (in %) in Morocco and Value added (in %) in Sri Lanka?
Give a very brief answer. 2.83. In the year 1994, what is the difference between the Value added (in %) in Kuwait and Value added (in %) in Macao?
Ensure brevity in your answer.  2.17. In the year 1994, what is the difference between the Value added (in %) of Kuwait and Value added (in %) of Morocco?
Your answer should be very brief. -2.2. In the year 1994, what is the difference between the Value added (in %) in Kuwait and Value added (in %) in Sri Lanka?
Your answer should be very brief. 0.41. In the year 1994, what is the difference between the Value added (in %) of Macao and Value added (in %) of Morocco?
Your response must be concise. -4.37. In the year 1994, what is the difference between the Value added (in %) in Macao and Value added (in %) in Sri Lanka?
Give a very brief answer. -1.76. In the year 1994, what is the difference between the Value added (in %) of Morocco and Value added (in %) of Sri Lanka?
Make the answer very short. 2.61. In the year 1995, what is the difference between the Value added (in %) in Kuwait and Value added (in %) in Macao?
Offer a terse response. 1.15. In the year 1995, what is the difference between the Value added (in %) in Kuwait and Value added (in %) in Morocco?
Provide a succinct answer. -2.51. In the year 1995, what is the difference between the Value added (in %) in Kuwait and Value added (in %) in Sri Lanka?
Your answer should be very brief. -0.82. In the year 1995, what is the difference between the Value added (in %) in Macao and Value added (in %) in Morocco?
Offer a very short reply. -3.66. In the year 1995, what is the difference between the Value added (in %) in Macao and Value added (in %) in Sri Lanka?
Give a very brief answer. -1.98. In the year 1995, what is the difference between the Value added (in %) in Morocco and Value added (in %) in Sri Lanka?
Your answer should be compact. 1.68. In the year 1996, what is the difference between the Value added (in %) in Kuwait and Value added (in %) in Macao?
Your answer should be very brief. 0.5. In the year 1996, what is the difference between the Value added (in %) of Kuwait and Value added (in %) of Morocco?
Make the answer very short. -2.77. In the year 1996, what is the difference between the Value added (in %) in Kuwait and Value added (in %) in Sri Lanka?
Your answer should be very brief. -0.77. In the year 1996, what is the difference between the Value added (in %) in Macao and Value added (in %) in Morocco?
Provide a short and direct response. -3.27. In the year 1996, what is the difference between the Value added (in %) in Macao and Value added (in %) in Sri Lanka?
Keep it short and to the point. -1.27. In the year 1996, what is the difference between the Value added (in %) of Morocco and Value added (in %) of Sri Lanka?
Make the answer very short. 2. In the year 1997, what is the difference between the Value added (in %) in Kuwait and Value added (in %) in Macao?
Make the answer very short. -1.33. In the year 1997, what is the difference between the Value added (in %) of Kuwait and Value added (in %) of Morocco?
Your response must be concise. -3.78. In the year 1997, what is the difference between the Value added (in %) of Kuwait and Value added (in %) of Sri Lanka?
Give a very brief answer. -2.2. In the year 1997, what is the difference between the Value added (in %) in Macao and Value added (in %) in Morocco?
Keep it short and to the point. -2.46. In the year 1997, what is the difference between the Value added (in %) of Macao and Value added (in %) of Sri Lanka?
Make the answer very short. -0.88. In the year 1997, what is the difference between the Value added (in %) in Morocco and Value added (in %) in Sri Lanka?
Offer a terse response. 1.58. In the year 1998, what is the difference between the Value added (in %) of Kuwait and Value added (in %) of Macao?
Offer a very short reply. 0.14. In the year 1998, what is the difference between the Value added (in %) of Kuwait and Value added (in %) of Morocco?
Provide a short and direct response. -1.96. In the year 1998, what is the difference between the Value added (in %) of Kuwait and Value added (in %) of Sri Lanka?
Provide a short and direct response. -1.29. In the year 1998, what is the difference between the Value added (in %) in Macao and Value added (in %) in Morocco?
Your response must be concise. -2.1. In the year 1998, what is the difference between the Value added (in %) in Macao and Value added (in %) in Sri Lanka?
Provide a succinct answer. -1.44. In the year 1998, what is the difference between the Value added (in %) in Morocco and Value added (in %) in Sri Lanka?
Provide a short and direct response. 0.67. What is the ratio of the Value added (in %) in Kuwait in 1991 to that in 1992?
Keep it short and to the point. 1.05. What is the ratio of the Value added (in %) of Macao in 1991 to that in 1992?
Your answer should be very brief. 1.46. What is the ratio of the Value added (in %) in Morocco in 1991 to that in 1992?
Offer a terse response. 0.79. What is the ratio of the Value added (in %) in Sri Lanka in 1991 to that in 1992?
Provide a succinct answer. 0.9. What is the ratio of the Value added (in %) of Kuwait in 1991 to that in 1993?
Provide a short and direct response. 1.08. What is the ratio of the Value added (in %) of Macao in 1991 to that in 1993?
Offer a very short reply. 1.36. What is the ratio of the Value added (in %) of Morocco in 1991 to that in 1993?
Give a very brief answer. 0.74. What is the ratio of the Value added (in %) in Sri Lanka in 1991 to that in 1993?
Offer a very short reply. 1.07. What is the ratio of the Value added (in %) in Kuwait in 1991 to that in 1994?
Your answer should be compact. 1.75. What is the ratio of the Value added (in %) in Macao in 1991 to that in 1994?
Make the answer very short. 1.67. What is the ratio of the Value added (in %) in Morocco in 1991 to that in 1994?
Provide a short and direct response. 0.78. What is the ratio of the Value added (in %) of Sri Lanka in 1991 to that in 1994?
Your answer should be very brief. 1.09. What is the ratio of the Value added (in %) of Kuwait in 1991 to that in 1995?
Give a very brief answer. 2.46. What is the ratio of the Value added (in %) of Macao in 1991 to that in 1995?
Provide a short and direct response. 1.47. What is the ratio of the Value added (in %) in Morocco in 1991 to that in 1995?
Make the answer very short. 0.88. What is the ratio of the Value added (in %) of Sri Lanka in 1991 to that in 1995?
Offer a terse response. 0.97. What is the ratio of the Value added (in %) of Kuwait in 1991 to that in 1996?
Ensure brevity in your answer.  2.75. What is the ratio of the Value added (in %) of Macao in 1991 to that in 1996?
Provide a short and direct response. 1.04. What is the ratio of the Value added (in %) of Morocco in 1991 to that in 1996?
Give a very brief answer. 0.87. What is the ratio of the Value added (in %) of Sri Lanka in 1991 to that in 1996?
Your answer should be compact. 1.07. What is the ratio of the Value added (in %) in Kuwait in 1991 to that in 1997?
Provide a short and direct response. 2.91. What is the ratio of the Value added (in %) of Macao in 1991 to that in 1997?
Make the answer very short. 0.48. What is the ratio of the Value added (in %) of Morocco in 1991 to that in 1997?
Keep it short and to the point. 0.73. What is the ratio of the Value added (in %) in Sri Lanka in 1991 to that in 1997?
Your response must be concise. 0.72. What is the ratio of the Value added (in %) of Kuwait in 1991 to that in 1998?
Offer a very short reply. 2.16. What is the ratio of the Value added (in %) of Macao in 1991 to that in 1998?
Provide a short and direct response. 0.65. What is the ratio of the Value added (in %) in Morocco in 1991 to that in 1998?
Provide a short and direct response. 0.92. What is the ratio of the Value added (in %) of Sri Lanka in 1991 to that in 1998?
Ensure brevity in your answer.  0.77. What is the ratio of the Value added (in %) of Kuwait in 1992 to that in 1993?
Keep it short and to the point. 1.04. What is the ratio of the Value added (in %) of Macao in 1992 to that in 1993?
Your answer should be compact. 0.94. What is the ratio of the Value added (in %) in Morocco in 1992 to that in 1993?
Keep it short and to the point. 0.93. What is the ratio of the Value added (in %) of Sri Lanka in 1992 to that in 1993?
Make the answer very short. 1.18. What is the ratio of the Value added (in %) in Kuwait in 1992 to that in 1994?
Provide a short and direct response. 1.67. What is the ratio of the Value added (in %) of Macao in 1992 to that in 1994?
Your answer should be very brief. 1.14. What is the ratio of the Value added (in %) in Morocco in 1992 to that in 1994?
Your answer should be compact. 0.98. What is the ratio of the Value added (in %) in Sri Lanka in 1992 to that in 1994?
Ensure brevity in your answer.  1.21. What is the ratio of the Value added (in %) in Kuwait in 1992 to that in 1995?
Your answer should be compact. 2.36. What is the ratio of the Value added (in %) in Macao in 1992 to that in 1995?
Keep it short and to the point. 1.01. What is the ratio of the Value added (in %) in Morocco in 1992 to that in 1995?
Offer a terse response. 1.11. What is the ratio of the Value added (in %) of Sri Lanka in 1992 to that in 1995?
Keep it short and to the point. 1.07. What is the ratio of the Value added (in %) of Kuwait in 1992 to that in 1996?
Offer a very short reply. 2.64. What is the ratio of the Value added (in %) of Macao in 1992 to that in 1996?
Provide a succinct answer. 0.72. What is the ratio of the Value added (in %) of Morocco in 1992 to that in 1996?
Your answer should be compact. 1.1. What is the ratio of the Value added (in %) of Sri Lanka in 1992 to that in 1996?
Provide a short and direct response. 1.18. What is the ratio of the Value added (in %) in Kuwait in 1992 to that in 1997?
Provide a succinct answer. 2.78. What is the ratio of the Value added (in %) in Macao in 1992 to that in 1997?
Your response must be concise. 0.33. What is the ratio of the Value added (in %) of Morocco in 1992 to that in 1997?
Offer a terse response. 0.92. What is the ratio of the Value added (in %) of Sri Lanka in 1992 to that in 1997?
Give a very brief answer. 0.79. What is the ratio of the Value added (in %) of Kuwait in 1992 to that in 1998?
Offer a very short reply. 2.07. What is the ratio of the Value added (in %) of Macao in 1992 to that in 1998?
Make the answer very short. 0.44. What is the ratio of the Value added (in %) in Morocco in 1992 to that in 1998?
Offer a very short reply. 1.17. What is the ratio of the Value added (in %) in Sri Lanka in 1992 to that in 1998?
Ensure brevity in your answer.  0.85. What is the ratio of the Value added (in %) in Kuwait in 1993 to that in 1994?
Keep it short and to the point. 1.61. What is the ratio of the Value added (in %) of Macao in 1993 to that in 1994?
Offer a very short reply. 1.22. What is the ratio of the Value added (in %) in Morocco in 1993 to that in 1994?
Give a very brief answer. 1.05. What is the ratio of the Value added (in %) of Sri Lanka in 1993 to that in 1994?
Offer a very short reply. 1.02. What is the ratio of the Value added (in %) in Kuwait in 1993 to that in 1995?
Offer a terse response. 2.27. What is the ratio of the Value added (in %) of Macao in 1993 to that in 1995?
Give a very brief answer. 1.08. What is the ratio of the Value added (in %) in Morocco in 1993 to that in 1995?
Make the answer very short. 1.18. What is the ratio of the Value added (in %) of Sri Lanka in 1993 to that in 1995?
Your response must be concise. 0.9. What is the ratio of the Value added (in %) in Kuwait in 1993 to that in 1996?
Your response must be concise. 2.54. What is the ratio of the Value added (in %) in Macao in 1993 to that in 1996?
Offer a very short reply. 0.77. What is the ratio of the Value added (in %) in Morocco in 1993 to that in 1996?
Provide a succinct answer. 1.18. What is the ratio of the Value added (in %) of Kuwait in 1993 to that in 1997?
Offer a terse response. 2.68. What is the ratio of the Value added (in %) in Macao in 1993 to that in 1997?
Make the answer very short. 0.35. What is the ratio of the Value added (in %) in Morocco in 1993 to that in 1997?
Keep it short and to the point. 0.99. What is the ratio of the Value added (in %) in Sri Lanka in 1993 to that in 1997?
Make the answer very short. 0.67. What is the ratio of the Value added (in %) of Kuwait in 1993 to that in 1998?
Your answer should be very brief. 1.99. What is the ratio of the Value added (in %) of Macao in 1993 to that in 1998?
Make the answer very short. 0.47. What is the ratio of the Value added (in %) of Morocco in 1993 to that in 1998?
Make the answer very short. 1.25. What is the ratio of the Value added (in %) of Sri Lanka in 1993 to that in 1998?
Provide a short and direct response. 0.72. What is the ratio of the Value added (in %) of Kuwait in 1994 to that in 1995?
Keep it short and to the point. 1.41. What is the ratio of the Value added (in %) in Macao in 1994 to that in 1995?
Keep it short and to the point. 0.88. What is the ratio of the Value added (in %) of Morocco in 1994 to that in 1995?
Ensure brevity in your answer.  1.12. What is the ratio of the Value added (in %) of Sri Lanka in 1994 to that in 1995?
Offer a terse response. 0.89. What is the ratio of the Value added (in %) of Kuwait in 1994 to that in 1996?
Give a very brief answer. 1.58. What is the ratio of the Value added (in %) of Macao in 1994 to that in 1996?
Provide a short and direct response. 0.63. What is the ratio of the Value added (in %) in Morocco in 1994 to that in 1996?
Provide a short and direct response. 1.12. What is the ratio of the Value added (in %) in Sri Lanka in 1994 to that in 1996?
Your response must be concise. 0.98. What is the ratio of the Value added (in %) in Kuwait in 1994 to that in 1997?
Offer a terse response. 1.67. What is the ratio of the Value added (in %) of Macao in 1994 to that in 1997?
Your answer should be compact. 0.29. What is the ratio of the Value added (in %) in Morocco in 1994 to that in 1997?
Provide a short and direct response. 0.94. What is the ratio of the Value added (in %) of Sri Lanka in 1994 to that in 1997?
Your response must be concise. 0.66. What is the ratio of the Value added (in %) of Kuwait in 1994 to that in 1998?
Offer a very short reply. 1.24. What is the ratio of the Value added (in %) of Macao in 1994 to that in 1998?
Your response must be concise. 0.39. What is the ratio of the Value added (in %) in Morocco in 1994 to that in 1998?
Provide a short and direct response. 1.19. What is the ratio of the Value added (in %) in Sri Lanka in 1994 to that in 1998?
Your answer should be compact. 0.71. What is the ratio of the Value added (in %) of Kuwait in 1995 to that in 1996?
Provide a succinct answer. 1.12. What is the ratio of the Value added (in %) of Macao in 1995 to that in 1996?
Offer a very short reply. 0.71. What is the ratio of the Value added (in %) of Sri Lanka in 1995 to that in 1996?
Make the answer very short. 1.1. What is the ratio of the Value added (in %) in Kuwait in 1995 to that in 1997?
Offer a terse response. 1.18. What is the ratio of the Value added (in %) in Macao in 1995 to that in 1997?
Offer a very short reply. 0.32. What is the ratio of the Value added (in %) in Morocco in 1995 to that in 1997?
Ensure brevity in your answer.  0.83. What is the ratio of the Value added (in %) of Sri Lanka in 1995 to that in 1997?
Your response must be concise. 0.74. What is the ratio of the Value added (in %) of Kuwait in 1995 to that in 1998?
Provide a short and direct response. 0.88. What is the ratio of the Value added (in %) of Macao in 1995 to that in 1998?
Give a very brief answer. 0.44. What is the ratio of the Value added (in %) in Morocco in 1995 to that in 1998?
Ensure brevity in your answer.  1.06. What is the ratio of the Value added (in %) in Sri Lanka in 1995 to that in 1998?
Your answer should be compact. 0.8. What is the ratio of the Value added (in %) in Kuwait in 1996 to that in 1997?
Give a very brief answer. 1.06. What is the ratio of the Value added (in %) in Macao in 1996 to that in 1997?
Offer a terse response. 0.46. What is the ratio of the Value added (in %) of Morocco in 1996 to that in 1997?
Your response must be concise. 0.84. What is the ratio of the Value added (in %) in Sri Lanka in 1996 to that in 1997?
Your answer should be compact. 0.67. What is the ratio of the Value added (in %) of Kuwait in 1996 to that in 1998?
Your answer should be very brief. 0.79. What is the ratio of the Value added (in %) in Macao in 1996 to that in 1998?
Offer a very short reply. 0.62. What is the ratio of the Value added (in %) in Morocco in 1996 to that in 1998?
Provide a short and direct response. 1.06. What is the ratio of the Value added (in %) of Sri Lanka in 1996 to that in 1998?
Keep it short and to the point. 0.72. What is the ratio of the Value added (in %) in Kuwait in 1997 to that in 1998?
Offer a very short reply. 0.74. What is the ratio of the Value added (in %) of Macao in 1997 to that in 1998?
Provide a short and direct response. 1.35. What is the ratio of the Value added (in %) in Morocco in 1997 to that in 1998?
Give a very brief answer. 1.27. What is the ratio of the Value added (in %) of Sri Lanka in 1997 to that in 1998?
Provide a succinct answer. 1.07. What is the difference between the highest and the second highest Value added (in %) of Kuwait?
Keep it short and to the point. 0.23. What is the difference between the highest and the second highest Value added (in %) in Macao?
Your answer should be compact. 0.83. What is the difference between the highest and the second highest Value added (in %) of Morocco?
Make the answer very short. 0.08. What is the difference between the highest and the second highest Value added (in %) in Sri Lanka?
Offer a very short reply. 0.27. What is the difference between the highest and the lowest Value added (in %) of Kuwait?
Your answer should be very brief. 3.53. What is the difference between the highest and the lowest Value added (in %) in Macao?
Provide a succinct answer. 2.27. What is the difference between the highest and the lowest Value added (in %) of Morocco?
Offer a very short reply. 1.52. What is the difference between the highest and the lowest Value added (in %) of Sri Lanka?
Give a very brief answer. 1.38. 